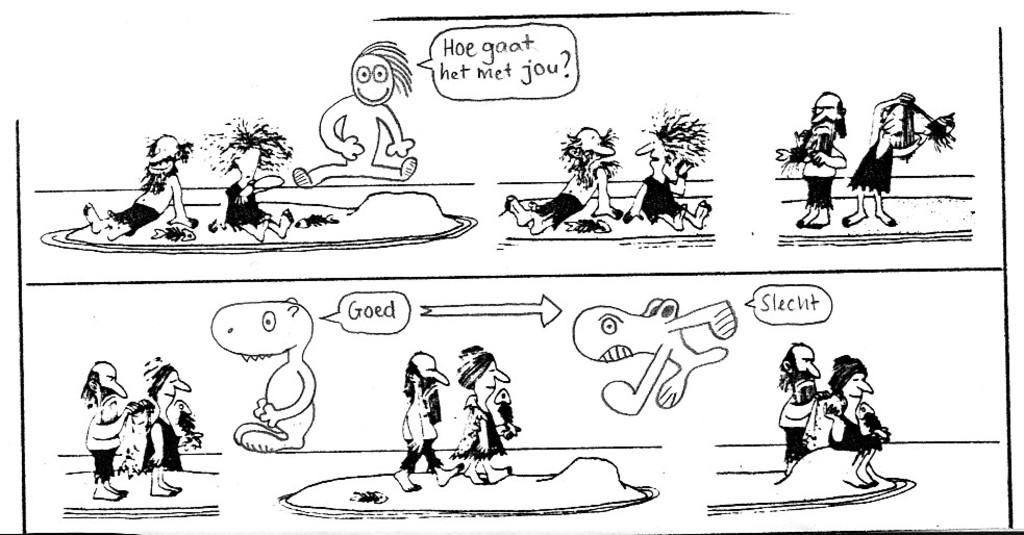What type of image is shown in the picture? The image is a drawing. What can be found within the drawing? The drawing contains depictions and text. How does the drawing increase the value of the pets in the image? There are no pets present in the image, and the drawing does not affect the value of any pets. 